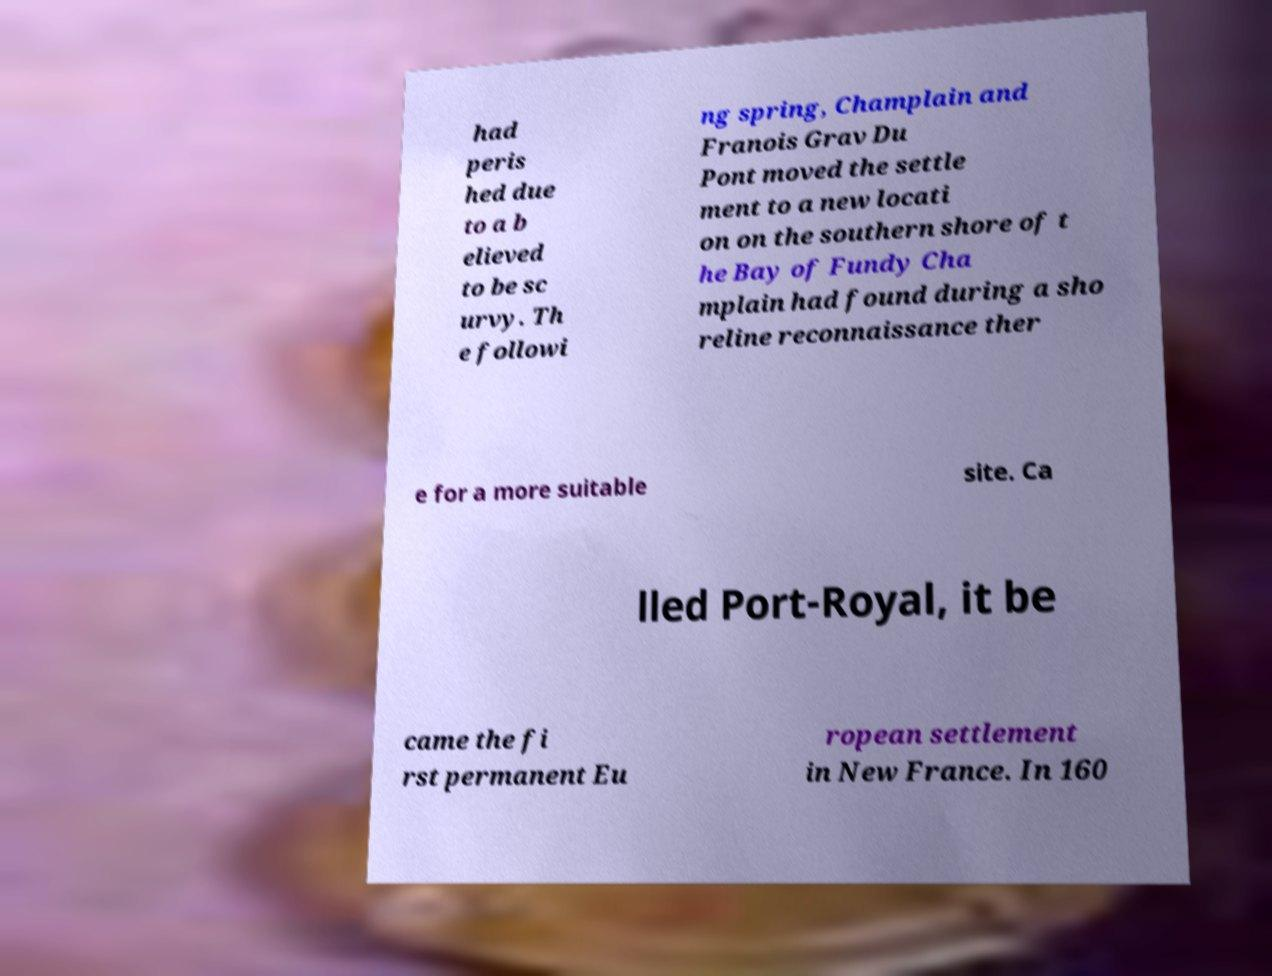Could you assist in decoding the text presented in this image and type it out clearly? had peris hed due to a b elieved to be sc urvy. Th e followi ng spring, Champlain and Franois Grav Du Pont moved the settle ment to a new locati on on the southern shore of t he Bay of Fundy Cha mplain had found during a sho reline reconnaissance ther e for a more suitable site. Ca lled Port-Royal, it be came the fi rst permanent Eu ropean settlement in New France. In 160 